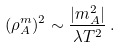Convert formula to latex. <formula><loc_0><loc_0><loc_500><loc_500>( \rho _ { A } ^ { m } ) ^ { 2 } \sim \frac { | m _ { A } ^ { 2 } | } { \lambda T ^ { 2 } } \, .</formula> 